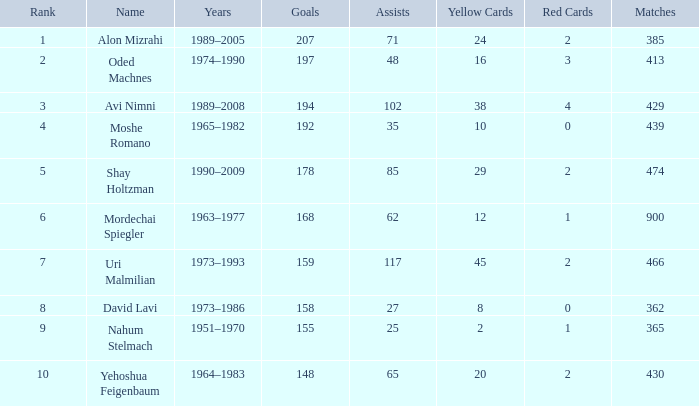What is the Rank of the player with 362 Matches? 8.0. 